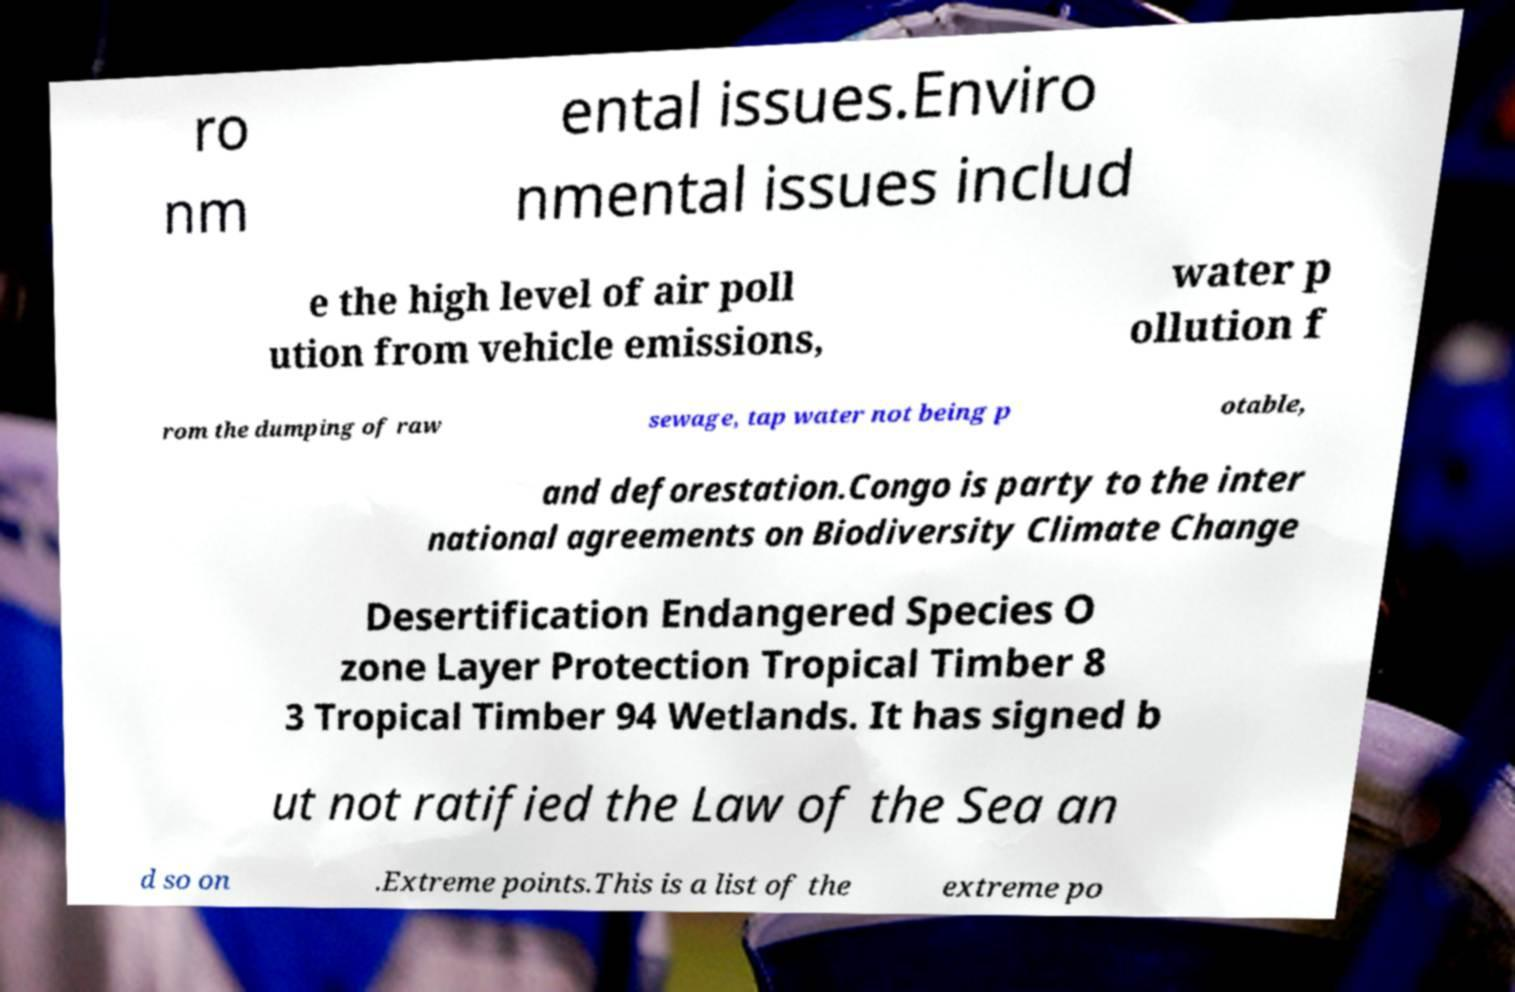Can you read and provide the text displayed in the image?This photo seems to have some interesting text. Can you extract and type it out for me? ro nm ental issues.Enviro nmental issues includ e the high level of air poll ution from vehicle emissions, water p ollution f rom the dumping of raw sewage, tap water not being p otable, and deforestation.Congo is party to the inter national agreements on Biodiversity Climate Change Desertification Endangered Species O zone Layer Protection Tropical Timber 8 3 Tropical Timber 94 Wetlands. It has signed b ut not ratified the Law of the Sea an d so on .Extreme points.This is a list of the extreme po 